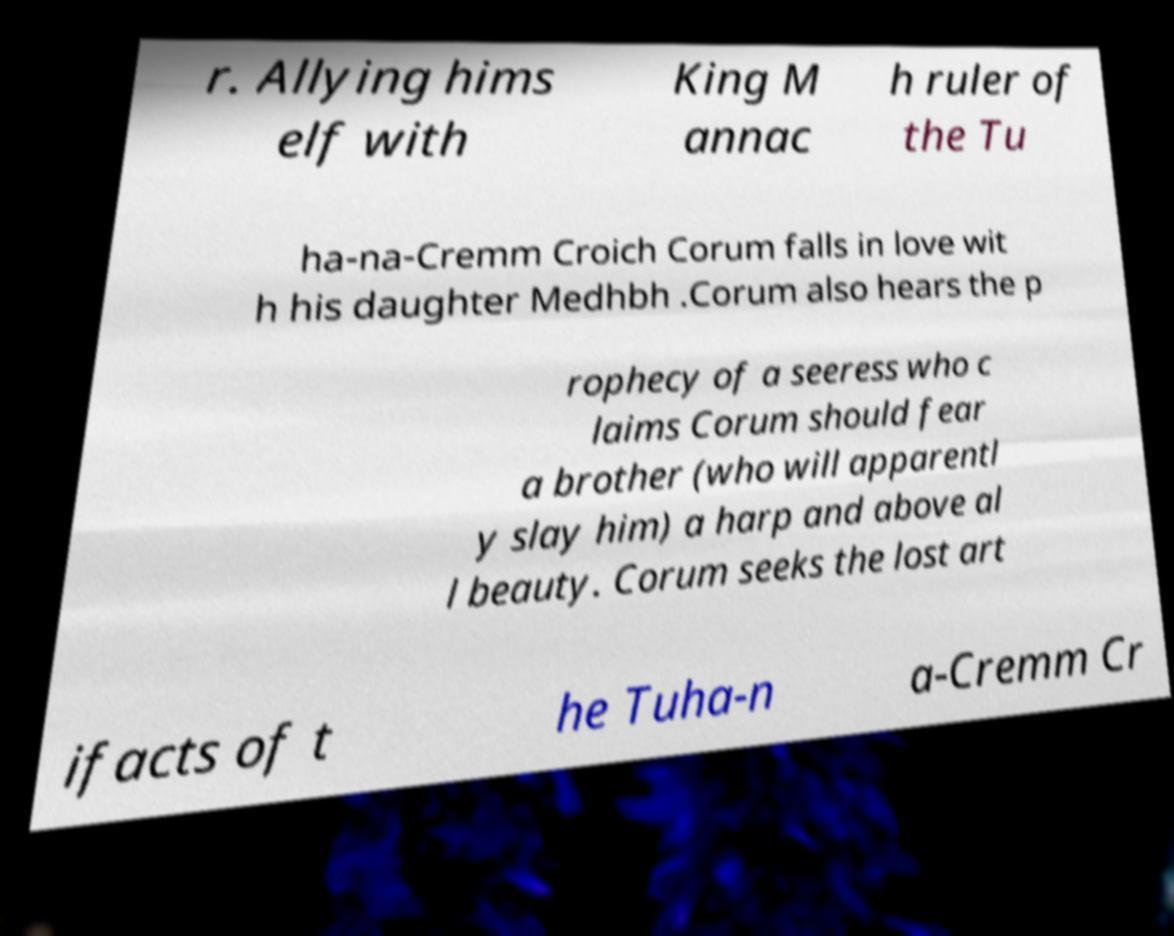I need the written content from this picture converted into text. Can you do that? r. Allying hims elf with King M annac h ruler of the Tu ha-na-Cremm Croich Corum falls in love wit h his daughter Medhbh .Corum also hears the p rophecy of a seeress who c laims Corum should fear a brother (who will apparentl y slay him) a harp and above al l beauty. Corum seeks the lost art ifacts of t he Tuha-n a-Cremm Cr 